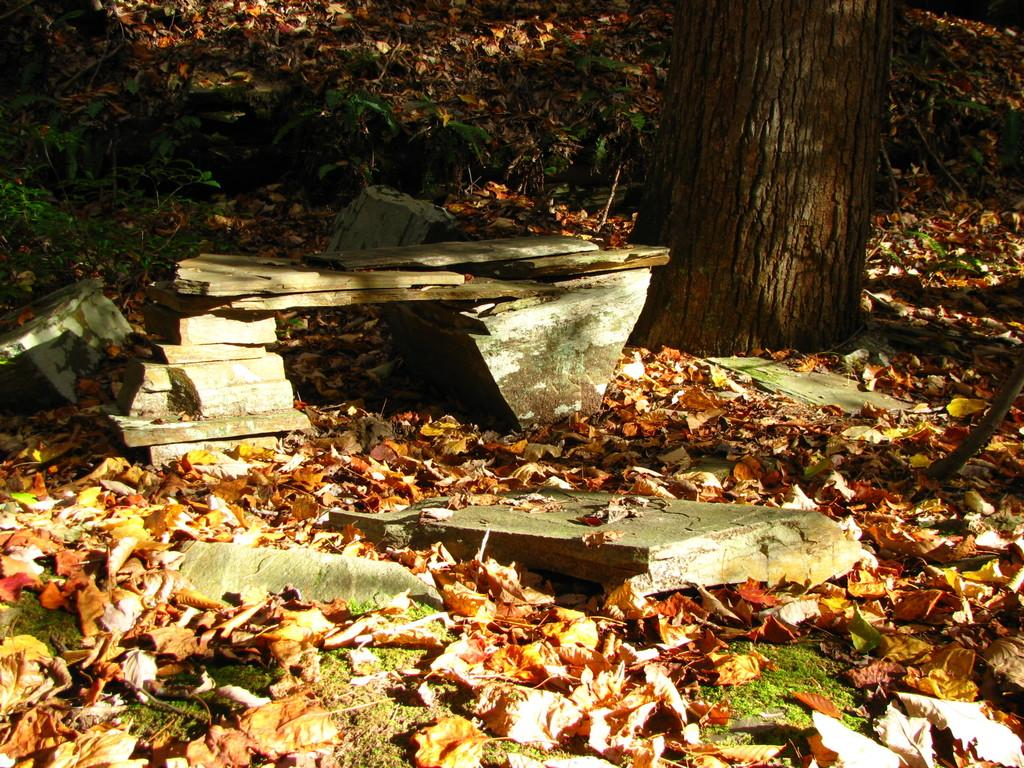What is the main subject of the image? The main subject of the image is a tree trunk. What action is happening to the tree leaves in the image? Tree leaves are falling down in the image. What type of surface is present in the image? There is a stone sheet in the image. How many mice can be seen playing with sticks in the image? There are no mice or sticks present in the image. Are there any babies visible in the image? There is no reference to babies in the image, which features a tree trunk, falling tree leaves, and a stone sheet. 